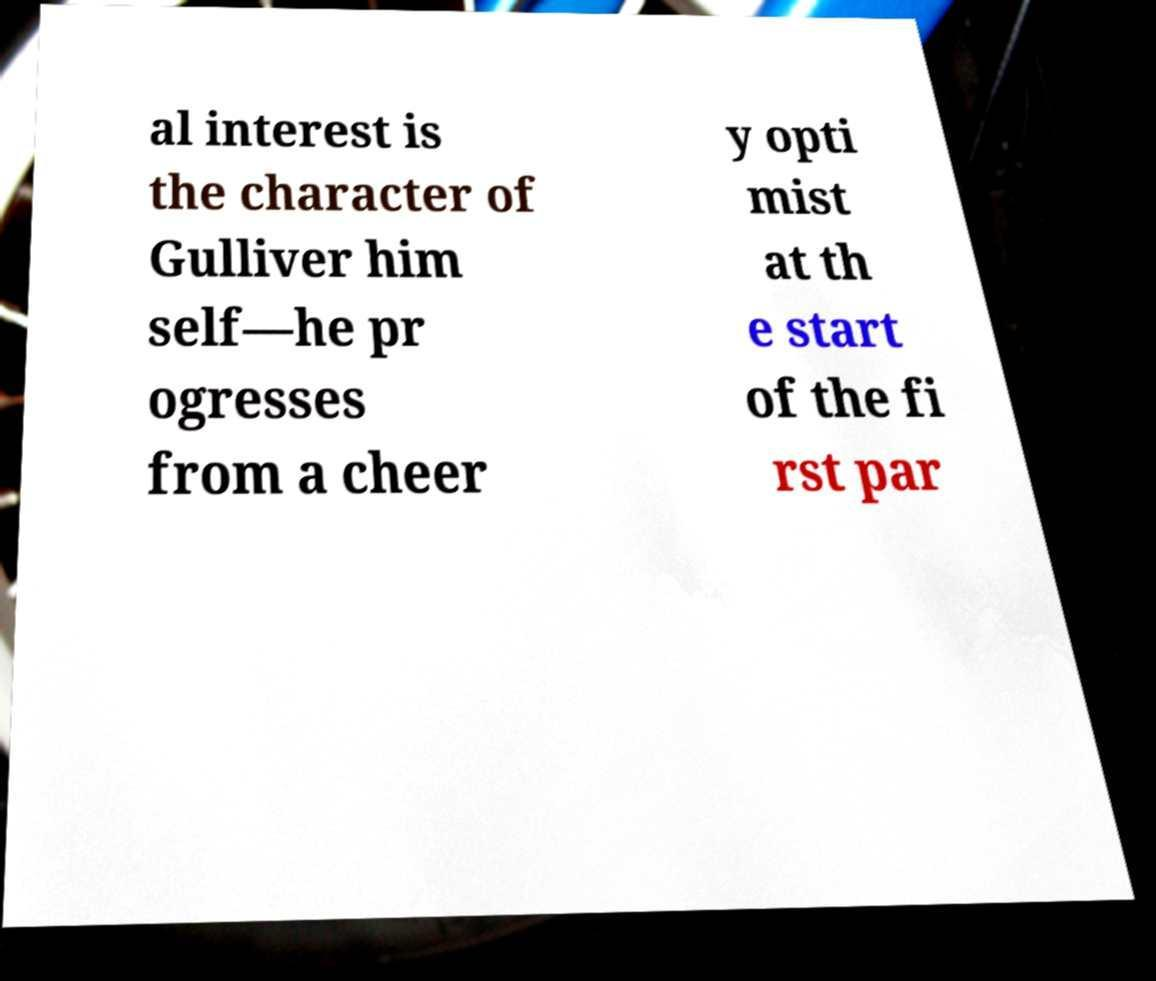Please read and relay the text visible in this image. What does it say? al interest is the character of Gulliver him self—he pr ogresses from a cheer y opti mist at th e start of the fi rst par 